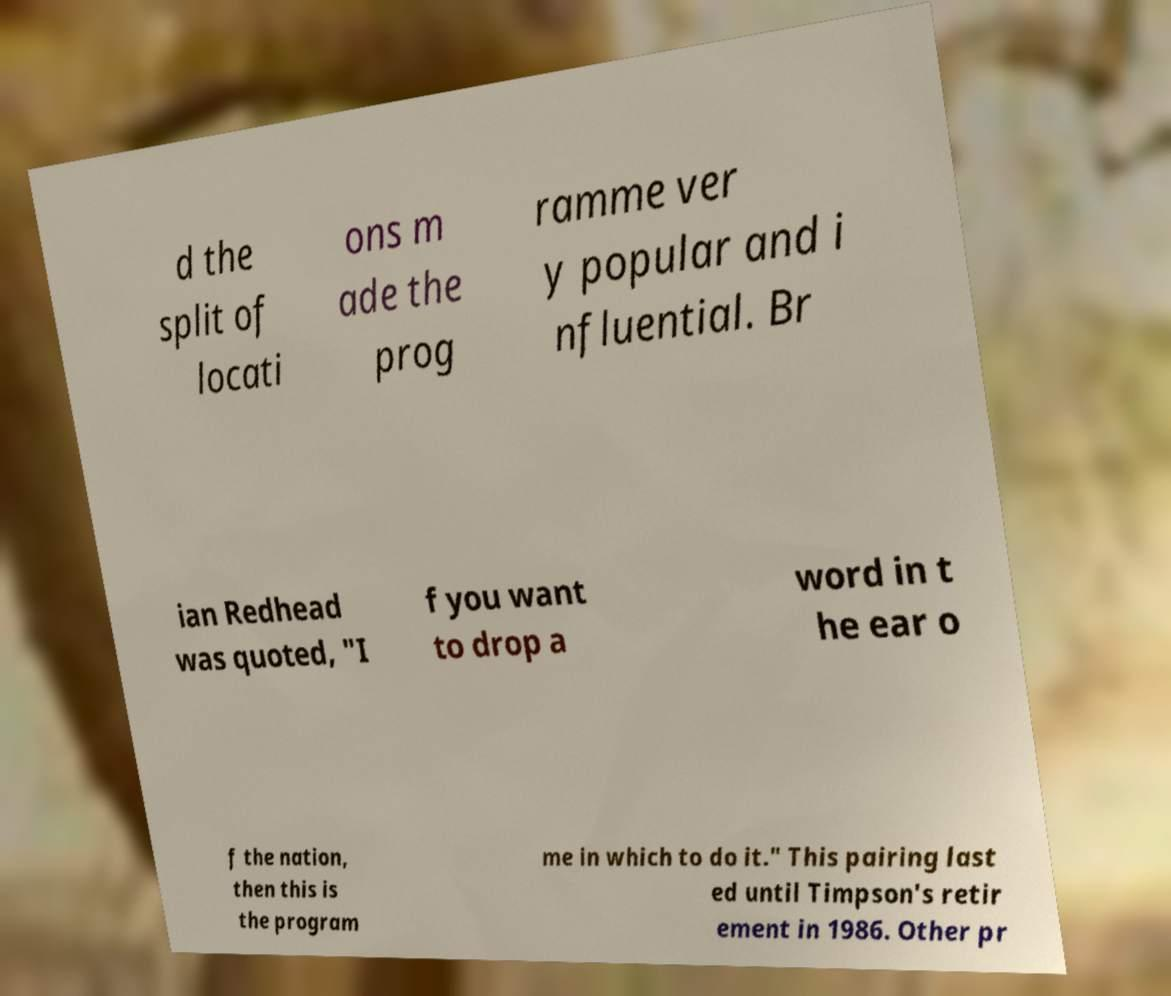Please read and relay the text visible in this image. What does it say? d the split of locati ons m ade the prog ramme ver y popular and i nfluential. Br ian Redhead was quoted, "I f you want to drop a word in t he ear o f the nation, then this is the program me in which to do it." This pairing last ed until Timpson's retir ement in 1986. Other pr 